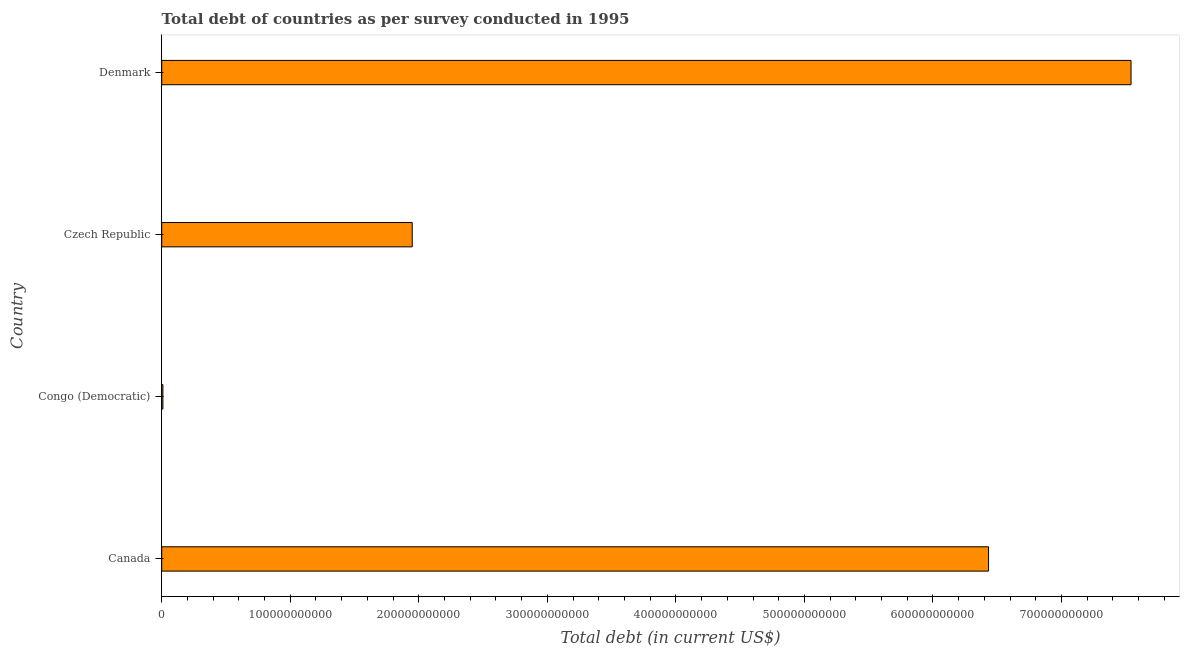Does the graph contain any zero values?
Provide a short and direct response. No. What is the title of the graph?
Offer a terse response. Total debt of countries as per survey conducted in 1995. What is the label or title of the X-axis?
Offer a very short reply. Total debt (in current US$). What is the label or title of the Y-axis?
Your answer should be compact. Country. What is the total debt in Congo (Democratic)?
Provide a short and direct response. 9.23e+08. Across all countries, what is the maximum total debt?
Your response must be concise. 7.54e+11. Across all countries, what is the minimum total debt?
Offer a very short reply. 9.23e+08. In which country was the total debt minimum?
Keep it short and to the point. Congo (Democratic). What is the sum of the total debt?
Your answer should be very brief. 1.59e+12. What is the difference between the total debt in Canada and Denmark?
Make the answer very short. -1.11e+11. What is the average total debt per country?
Make the answer very short. 3.98e+11. What is the median total debt?
Make the answer very short. 4.19e+11. What is the ratio of the total debt in Congo (Democratic) to that in Denmark?
Provide a short and direct response. 0. Is the total debt in Czech Republic less than that in Denmark?
Ensure brevity in your answer.  Yes. What is the difference between the highest and the second highest total debt?
Provide a short and direct response. 1.11e+11. What is the difference between the highest and the lowest total debt?
Provide a short and direct response. 7.53e+11. Are all the bars in the graph horizontal?
Give a very brief answer. Yes. How many countries are there in the graph?
Ensure brevity in your answer.  4. What is the difference between two consecutive major ticks on the X-axis?
Make the answer very short. 1.00e+11. What is the Total debt (in current US$) in Canada?
Offer a terse response. 6.43e+11. What is the Total debt (in current US$) of Congo (Democratic)?
Ensure brevity in your answer.  9.23e+08. What is the Total debt (in current US$) in Czech Republic?
Give a very brief answer. 1.95e+11. What is the Total debt (in current US$) in Denmark?
Ensure brevity in your answer.  7.54e+11. What is the difference between the Total debt (in current US$) in Canada and Congo (Democratic)?
Give a very brief answer. 6.42e+11. What is the difference between the Total debt (in current US$) in Canada and Czech Republic?
Your response must be concise. 4.48e+11. What is the difference between the Total debt (in current US$) in Canada and Denmark?
Provide a succinct answer. -1.11e+11. What is the difference between the Total debt (in current US$) in Congo (Democratic) and Czech Republic?
Offer a terse response. -1.94e+11. What is the difference between the Total debt (in current US$) in Congo (Democratic) and Denmark?
Give a very brief answer. -7.53e+11. What is the difference between the Total debt (in current US$) in Czech Republic and Denmark?
Ensure brevity in your answer.  -5.59e+11. What is the ratio of the Total debt (in current US$) in Canada to that in Congo (Democratic)?
Keep it short and to the point. 696.6. What is the ratio of the Total debt (in current US$) in Canada to that in Denmark?
Give a very brief answer. 0.85. What is the ratio of the Total debt (in current US$) in Congo (Democratic) to that in Czech Republic?
Provide a succinct answer. 0.01. What is the ratio of the Total debt (in current US$) in Congo (Democratic) to that in Denmark?
Your answer should be very brief. 0. What is the ratio of the Total debt (in current US$) in Czech Republic to that in Denmark?
Give a very brief answer. 0.26. 